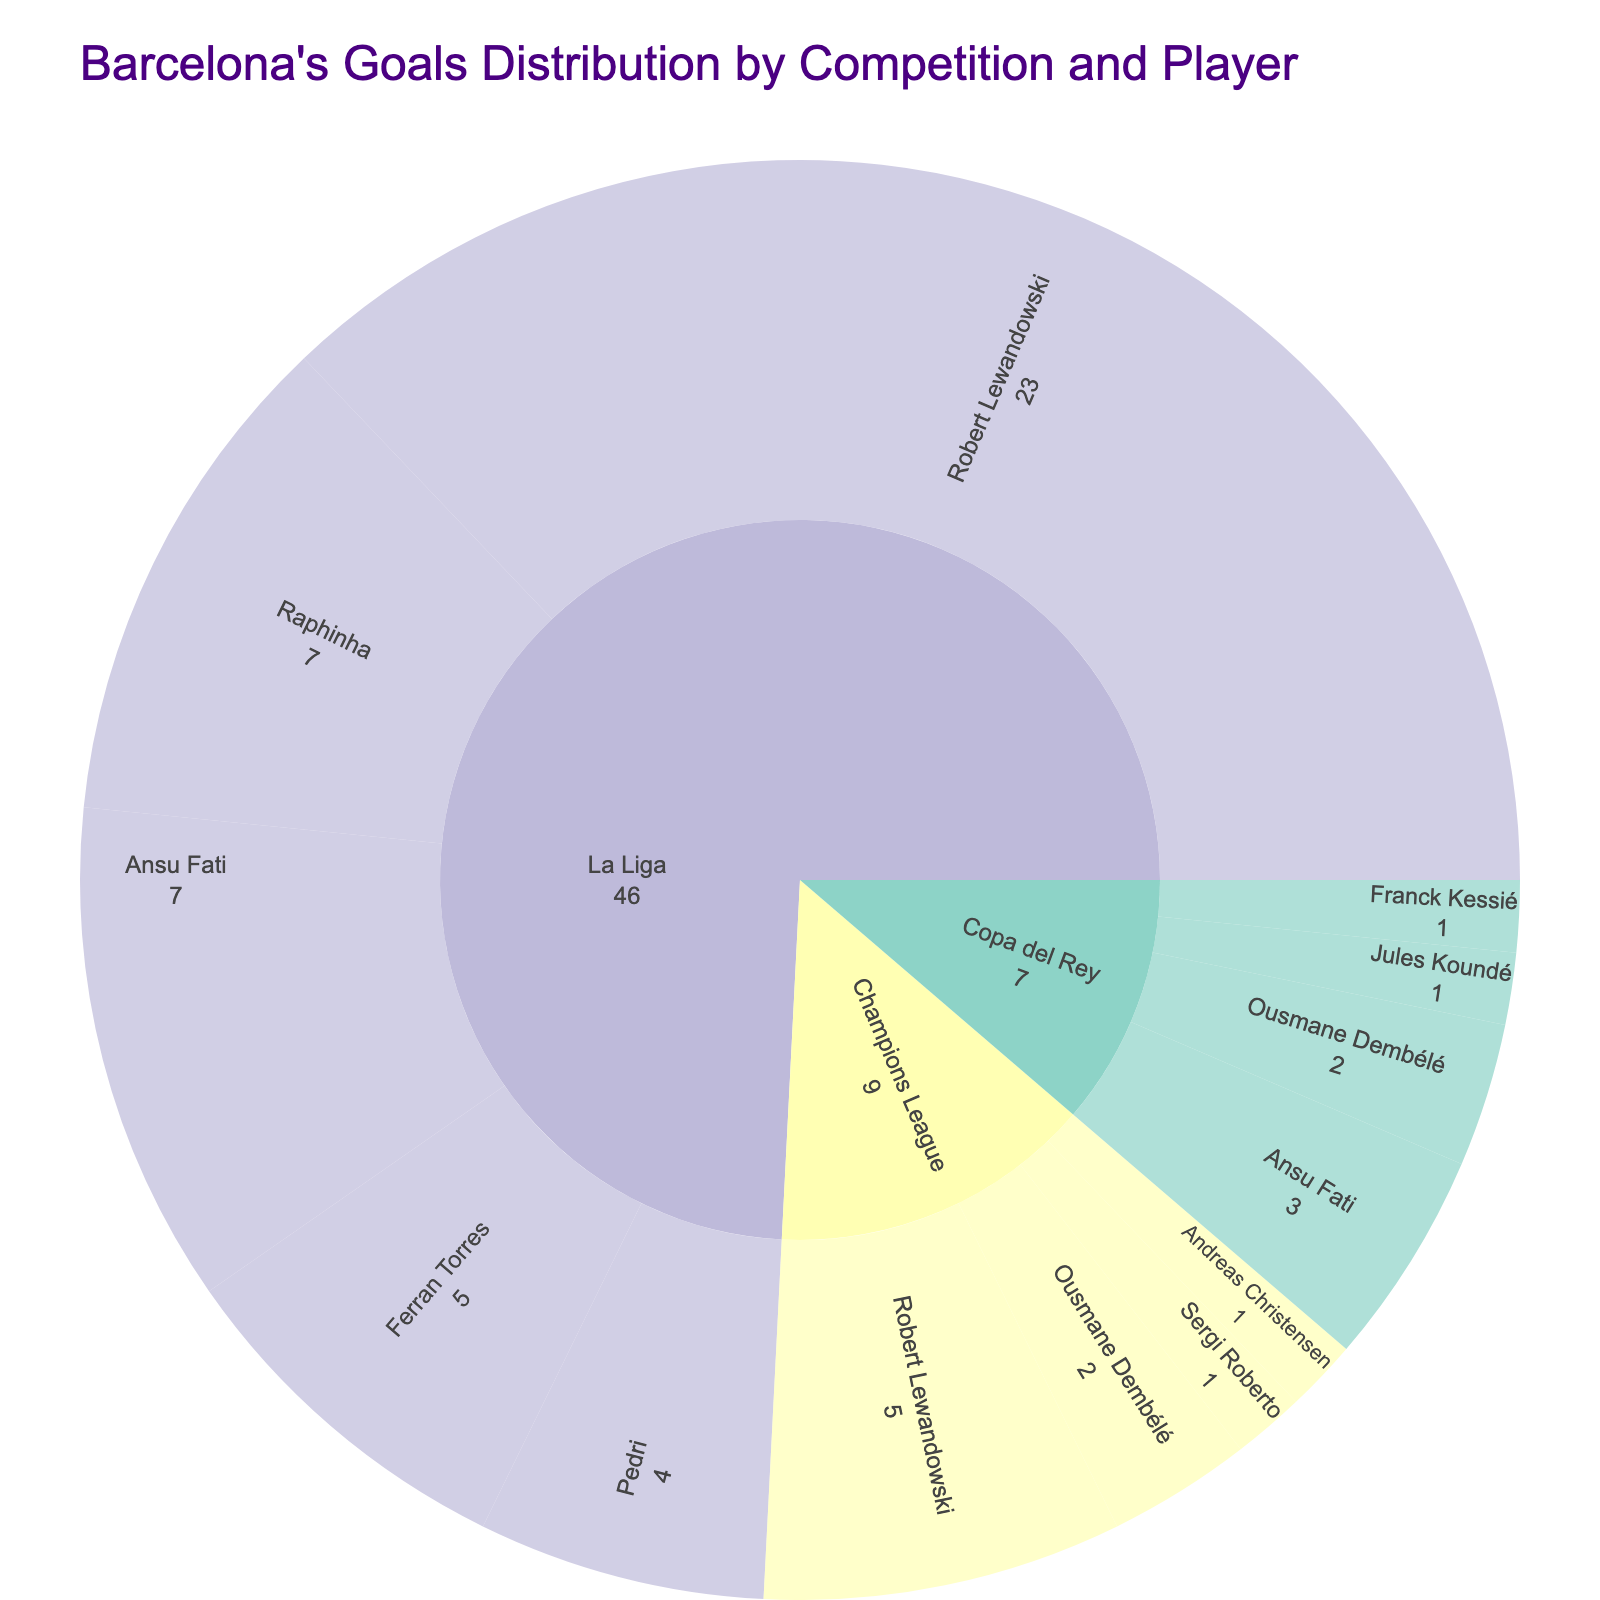What's the title of the figure? The title is displayed at the top of the figure in a bold format. It describes the overall content of the plot.
Answer: Barcelona's Goals Distribution by Competition and Player Which player scored the most goals in La Liga? Observe the La Liga section in the figure and find the player with the biggest segment.
Answer: Robert Lewandowski How many goals did Ansu Fati score in all competitions? Locate Ansu Fati in different competitions and sum up his goals: 7 in La Liga and 3 in Copa del Rey.
Answer: 10 Who scored more goals in total, Raphinha or Ousmane Dembélé? Raphinha scored all his 7 goals in La Liga, while Ousmane Dembélé scored 2 in Champions League and 2 in Copa del Rey, totaling 4. 7 is greater than 4.
Answer: Raphinha Compare the total goals scored by Robert Lewandowski in La Liga and Champions League. Which competition had more goals? Refer to Robert Lewandowski's segments in La Liga and Champions League, where he scored 23 and 5 respectively. 23 is more than 5.
Answer: La Liga Which competition had the most even distribution of goals among different players? Check the width of segments for each competition. A more even distribution means segments are relatively equal in size. Copa del Rey shows more balanced segments compared to La Liga and Champions League.
Answer: Copa del Rey How many competitions did Ousmane Dembélé score in? Identify the segments representing Ousmane Dembélé. There are segments in Champions League and Copa del Rey, totaling 2 competitions.
Answer: 2 What's the difference in goals scored between Pedri in La Liga and Ousmane Dembélé in Champions League? Subtract the goals of Ousmane Dembélé in Champions League (2) from Pedri's goals in La Liga (4). 4 - 2 = 2.
Answer: 2 